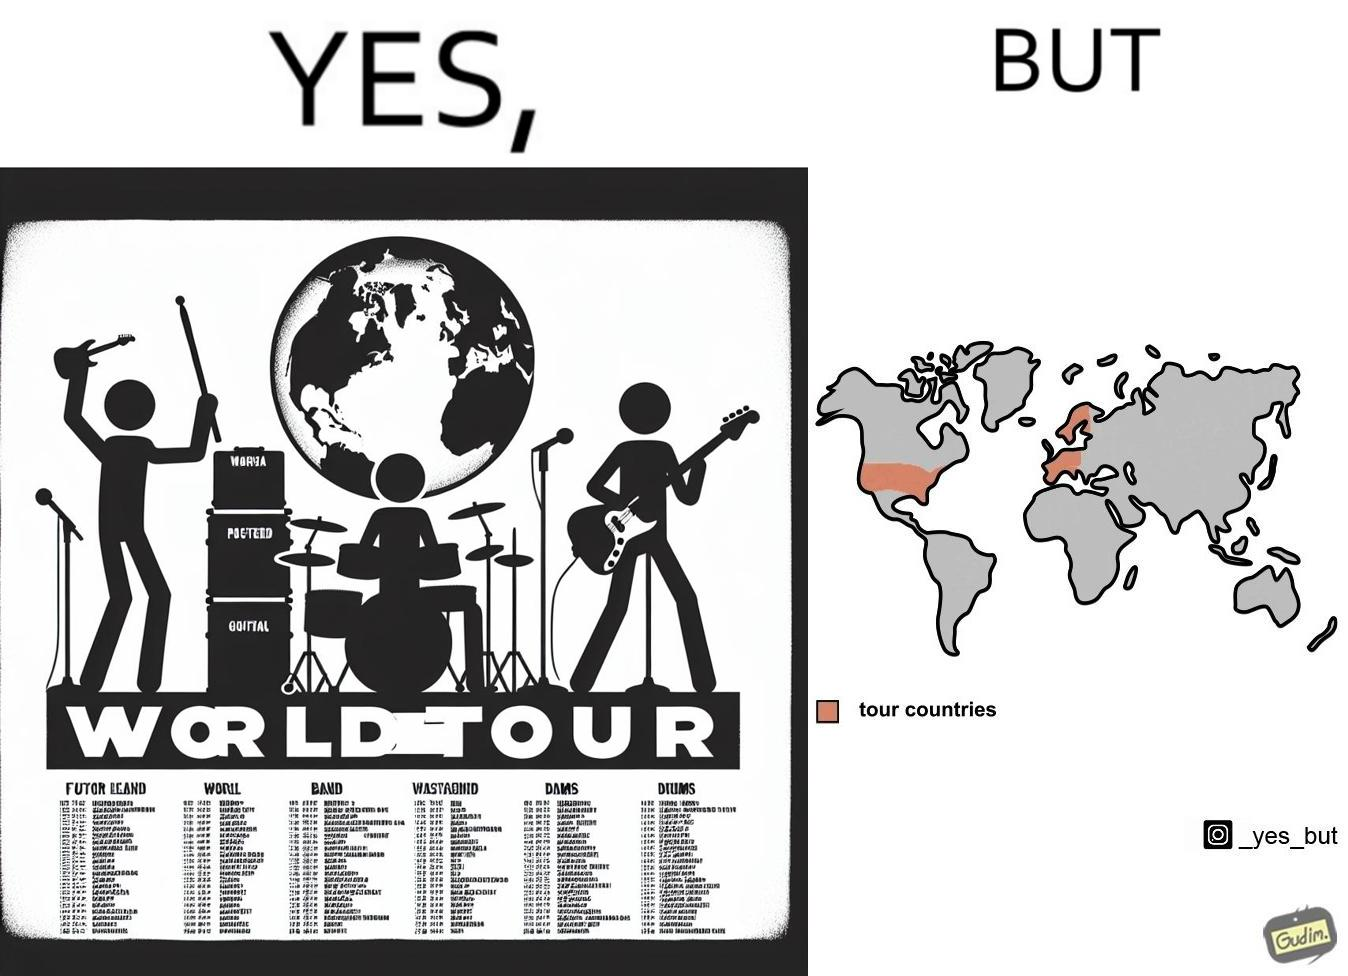What is shown in the left half versus the right half of this image? In the left part of the image: a poster of some music band's world tour In the right part of the image: a world map highlighting some parts as tour countries 